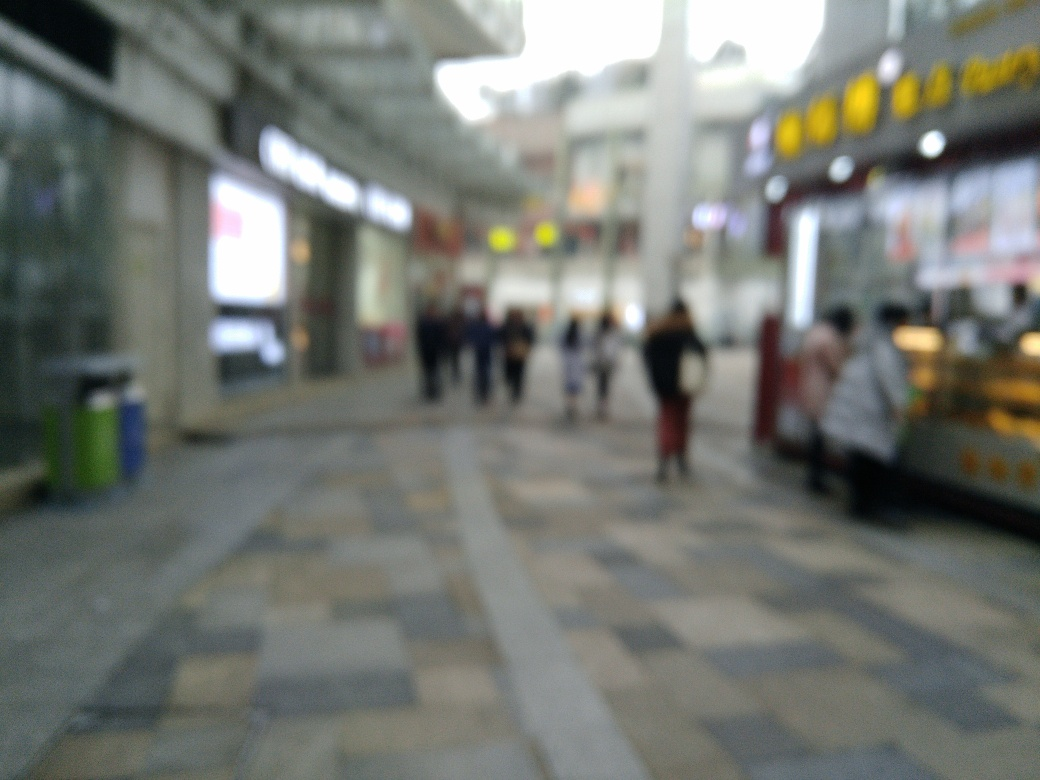What time of day does this image seem to capture? The lighting in the image suggests it might be daytime, but due to the blurriness, it's not possible to determine the exact time with certainty. 